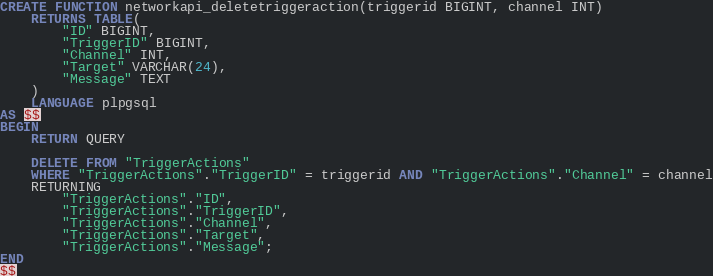<code> <loc_0><loc_0><loc_500><loc_500><_SQL_>
CREATE FUNCTION networkapi_deletetriggeraction(triggerid BIGINT, channel INT)
    RETURNS TABLE(
        "ID" BIGINT,
        "TriggerID" BIGINT,
        "Channel" INT,
        "Target" VARCHAR(24),
        "Message" TEXT
    )
    LANGUAGE plpgsql
AS $$
BEGIN
	RETURN QUERY

    DELETE FROM "TriggerActions"
    WHERE "TriggerActions"."TriggerID" = triggerid AND "TriggerActions"."Channel" = channel
	RETURNING
        "TriggerActions"."ID",
	    "TriggerActions"."TriggerID",
	    "TriggerActions"."Channel",
	    "TriggerActions"."Target",
	    "TriggerActions"."Message";
END
$$
</code> 